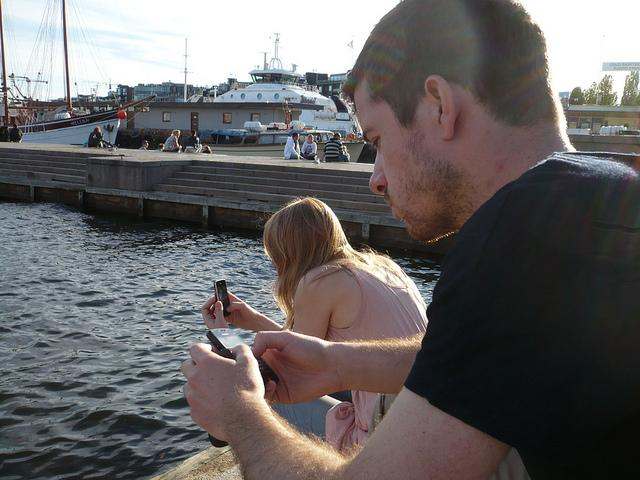If the man threw his phone 2 meters forward where would it land? Please explain your reasoning. in water. The man is sitting near water. 